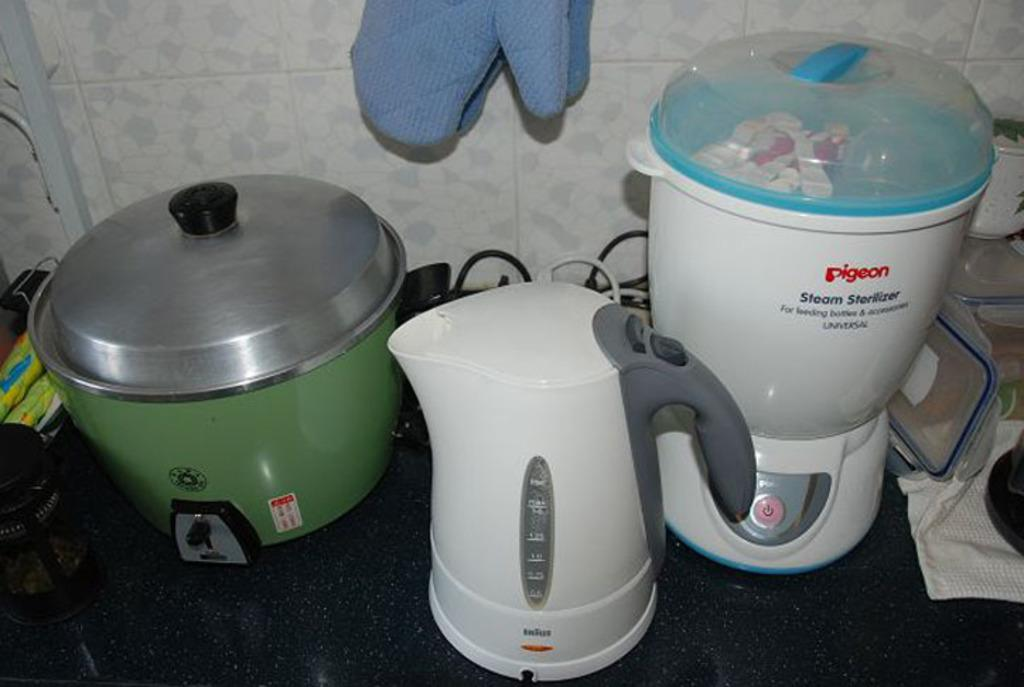Provide a one-sentence caption for the provided image. A Pigeon brand steam sterilizer on a kitchen counter. 